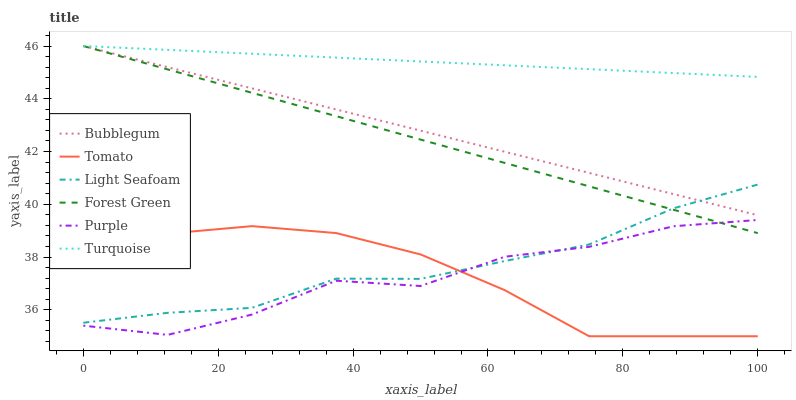Does Purple have the minimum area under the curve?
Answer yes or no. Yes. Does Turquoise have the maximum area under the curve?
Answer yes or no. Yes. Does Turquoise have the minimum area under the curve?
Answer yes or no. No. Does Purple have the maximum area under the curve?
Answer yes or no. No. Is Forest Green the smoothest?
Answer yes or no. Yes. Is Purple the roughest?
Answer yes or no. Yes. Is Turquoise the smoothest?
Answer yes or no. No. Is Turquoise the roughest?
Answer yes or no. No. Does Tomato have the lowest value?
Answer yes or no. Yes. Does Purple have the lowest value?
Answer yes or no. No. Does Forest Green have the highest value?
Answer yes or no. Yes. Does Purple have the highest value?
Answer yes or no. No. Is Purple less than Bubblegum?
Answer yes or no. Yes. Is Forest Green greater than Tomato?
Answer yes or no. Yes. Does Bubblegum intersect Light Seafoam?
Answer yes or no. Yes. Is Bubblegum less than Light Seafoam?
Answer yes or no. No. Is Bubblegum greater than Light Seafoam?
Answer yes or no. No. Does Purple intersect Bubblegum?
Answer yes or no. No. 